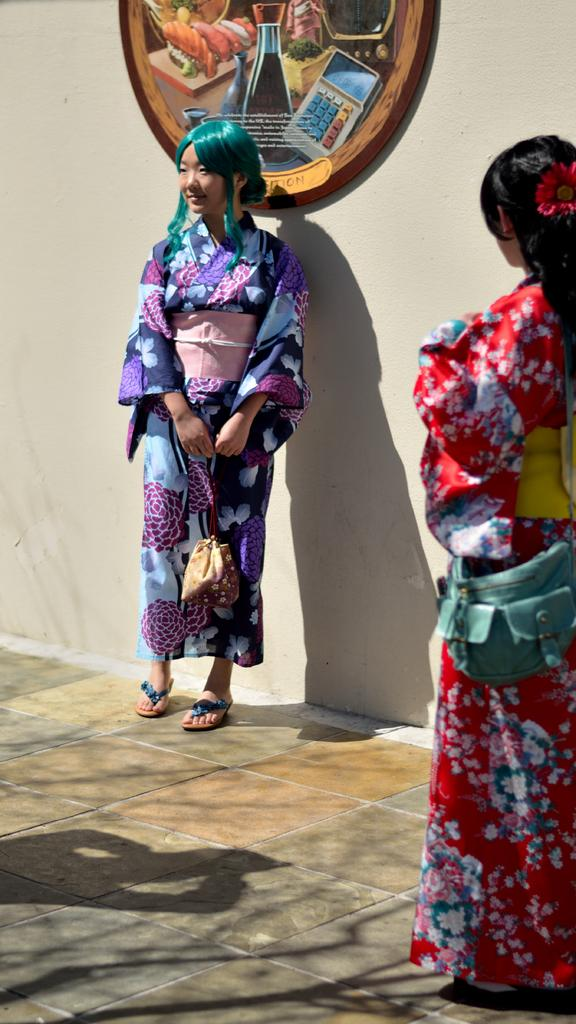How many women are in the image? There are two women standing in the image. What are the women wearing? The women are wearing clothes. What are the women carrying? The women are carrying bags. What type of path can be seen in the image? There is a footpath in the image. What is the background of the image? There is a wall in the image, and a wooden circular board is attached to it. Can you see any sheep in the image? No, there are no sheep present in the image. What type of van can be seen parked on the footpath? There is no van present in the image; it only features two women, a footpath, a wall, and a wooden circular board. 